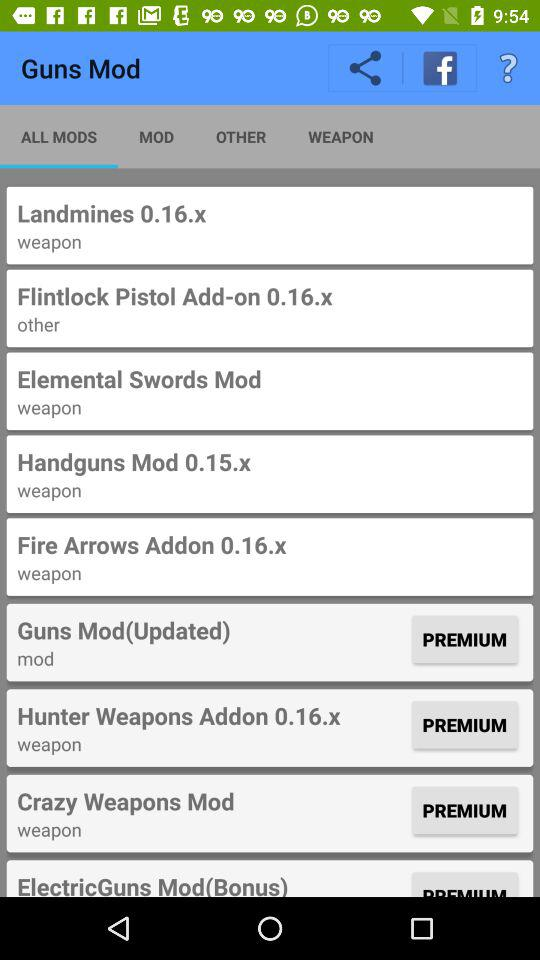How many of the items are premium?
Answer the question using a single word or phrase. 4 